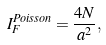<formula> <loc_0><loc_0><loc_500><loc_500>I _ { F } ^ { P o i s s o n } = \frac { 4 N } { a ^ { 2 } } ,</formula> 